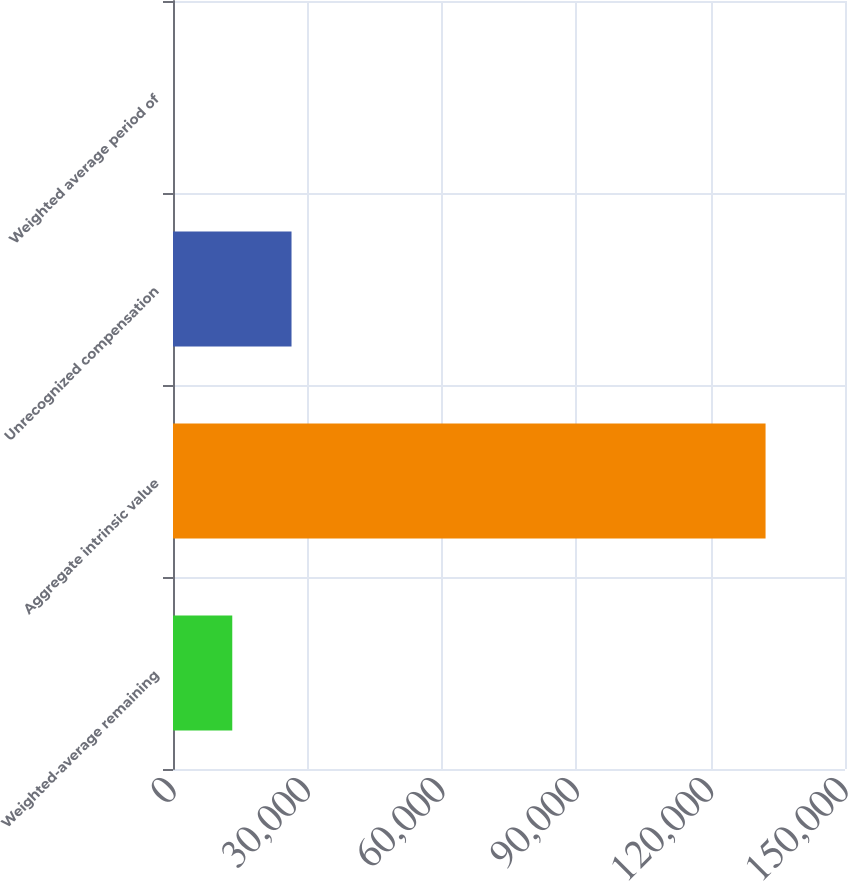Convert chart. <chart><loc_0><loc_0><loc_500><loc_500><bar_chart><fcel>Weighted-average remaining<fcel>Aggregate intrinsic value<fcel>Unrecognized compensation<fcel>Weighted average period of<nl><fcel>13229<fcel>132268<fcel>26455.6<fcel>2.46<nl></chart> 